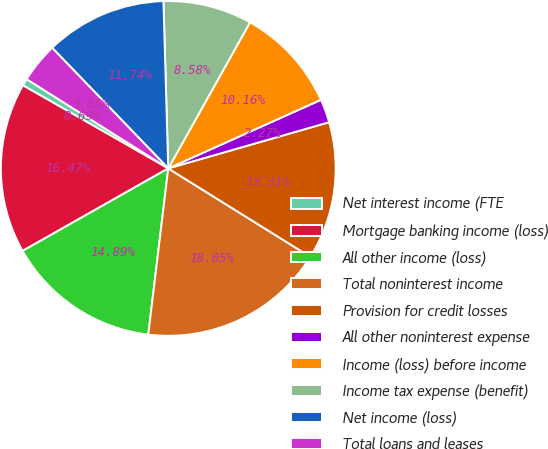Convert chart to OTSL. <chart><loc_0><loc_0><loc_500><loc_500><pie_chart><fcel>Net interest income (FTE<fcel>Mortgage banking income (loss)<fcel>All other income (loss)<fcel>Total noninterest income<fcel>Provision for credit losses<fcel>All other noninterest expense<fcel>Income (loss) before income<fcel>Income tax expense (benefit)<fcel>Net income (loss)<fcel>Total loans and leases<nl><fcel>0.69%<fcel>16.47%<fcel>14.89%<fcel>18.05%<fcel>13.31%<fcel>2.27%<fcel>10.16%<fcel>8.58%<fcel>11.74%<fcel>3.85%<nl></chart> 